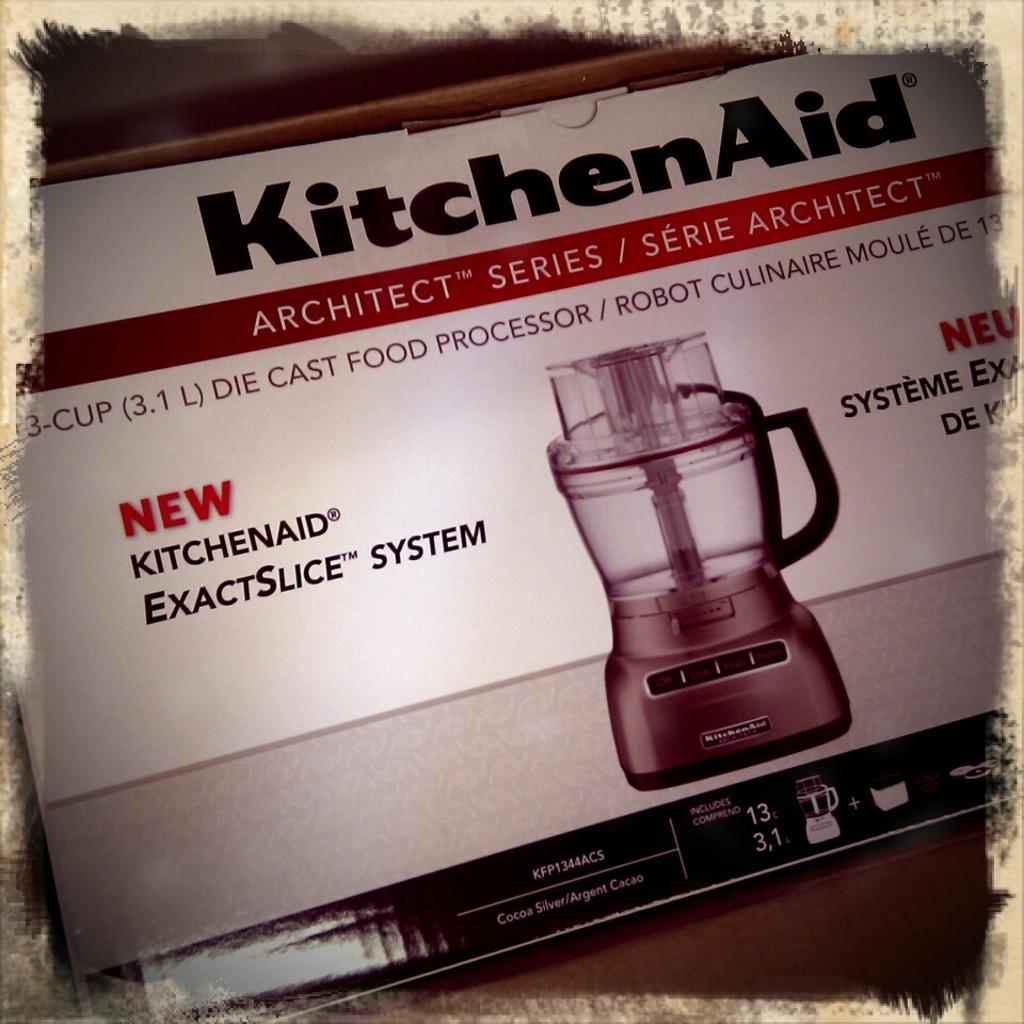Could you give a brief overview of what you see in this image? This picture might be a photo frame. In this image, we can see picture of a book. In the book, we can see an electronic machine and some text written on it. 